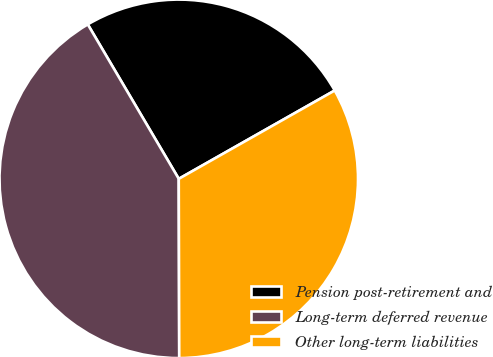Convert chart. <chart><loc_0><loc_0><loc_500><loc_500><pie_chart><fcel>Pension post-retirement and<fcel>Long-term deferred revenue<fcel>Other long-term liabilities<nl><fcel>25.27%<fcel>41.57%<fcel>33.16%<nl></chart> 